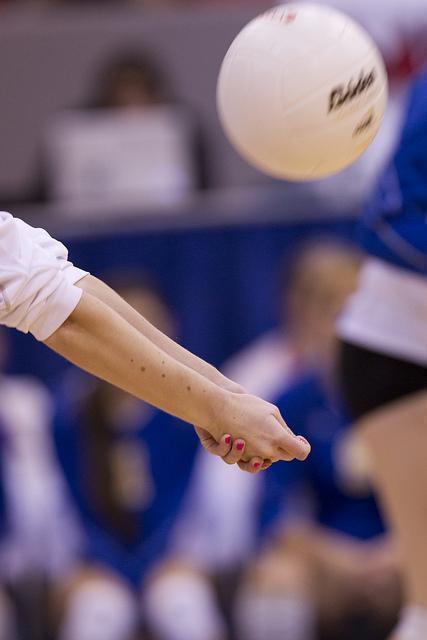How many people are there?
Give a very brief answer. 5. 